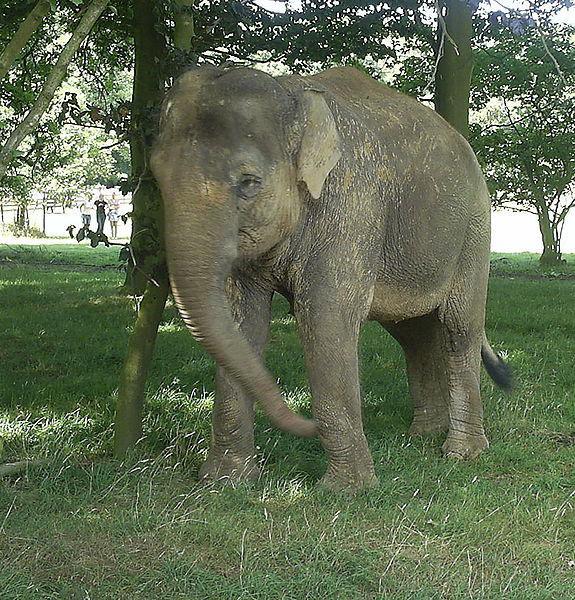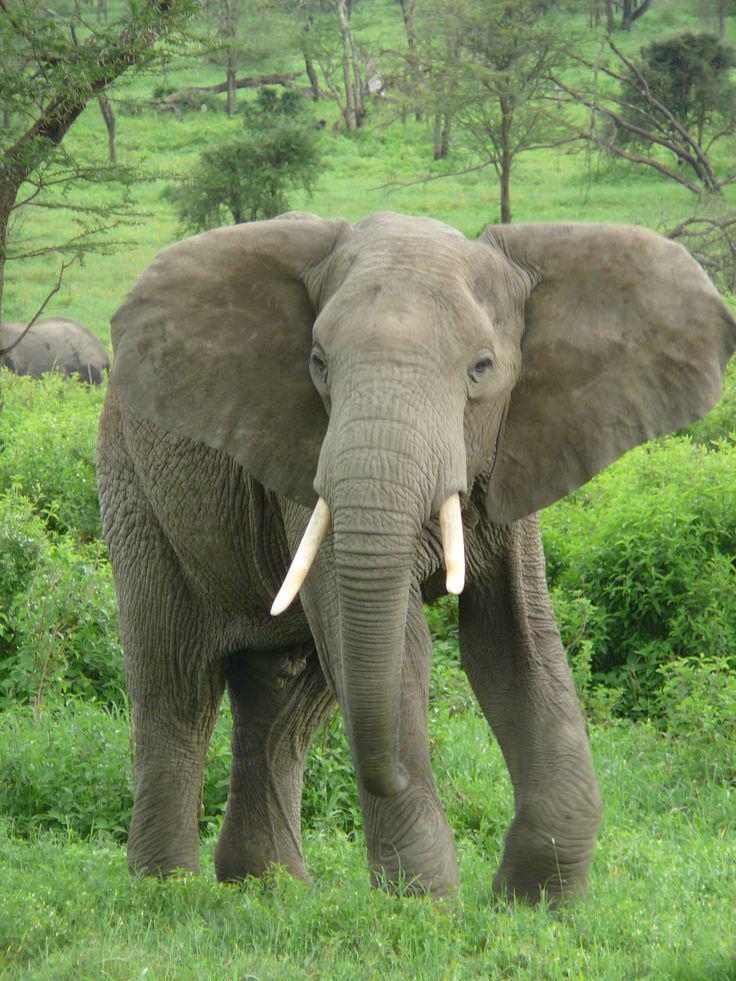The first image is the image on the left, the second image is the image on the right. Assess this claim about the two images: "There are two elephants". Correct or not? Answer yes or no. Yes. 